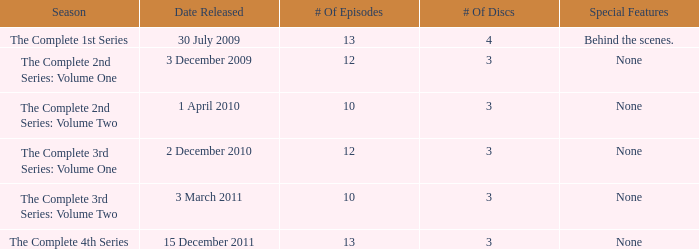What day was the complete 2nd series: volume one released? 3 December 2009. 